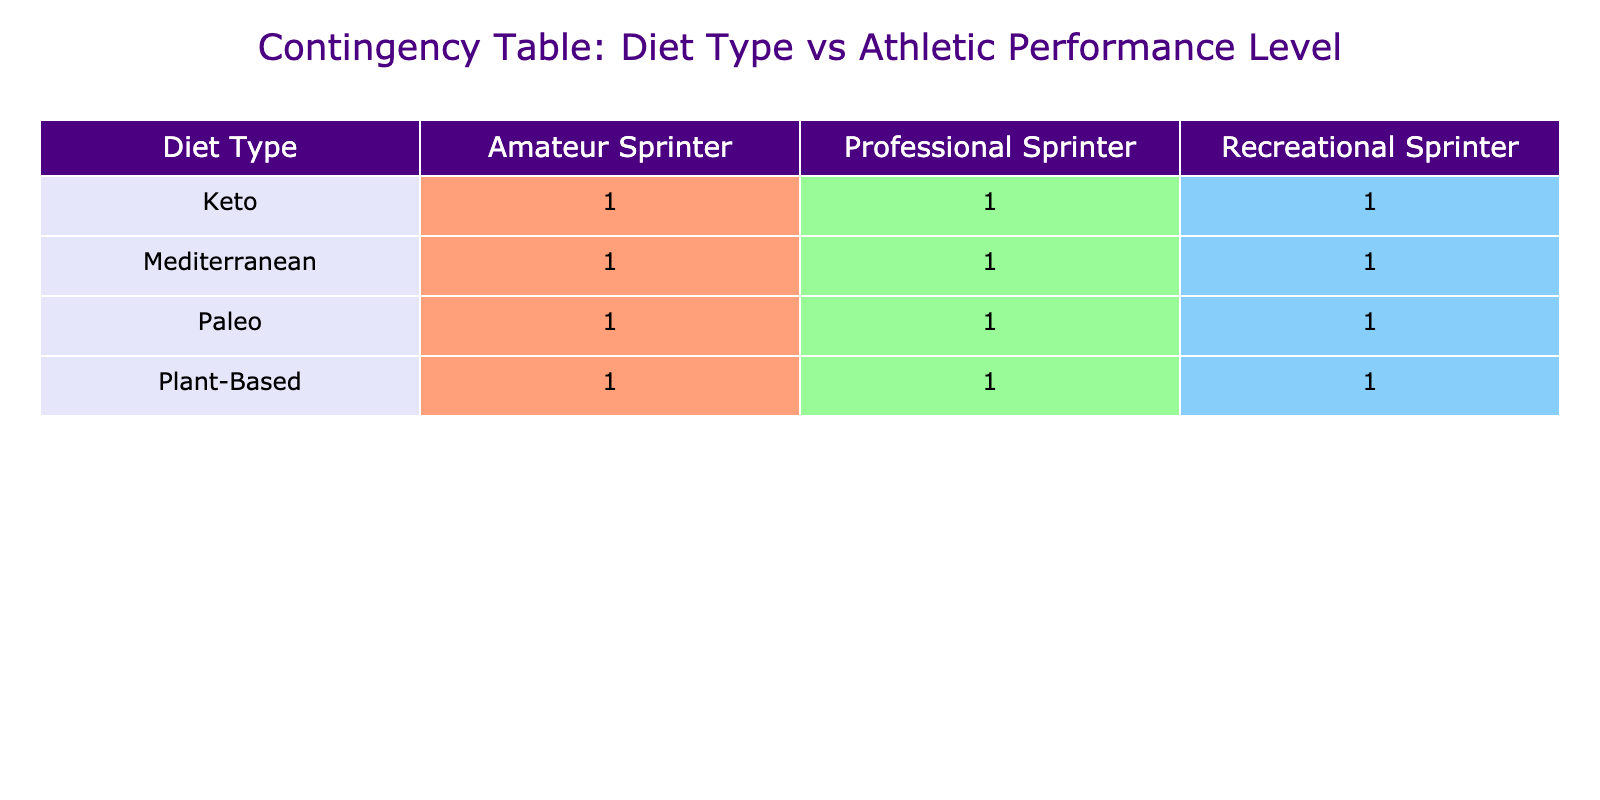What is the daily caloric intake for Professional Sprinters on a Mediterranean diet? From the table, the row for the Mediterranean diet under the Professional Sprinter category shows a daily caloric intake of 2800 calories.
Answer: 2800 calories How many grams of protein do Amateur Sprinters consuming a Keto diet take? Looking at the Keto diet row for the Amateur Sprinter column, the protein intake is listed as 100 grams.
Answer: 100 grams True or False: Recreational Sprinters have a higher average daily caloric intake than Amateur Sprinters across all diet types. To determine this, we calculate the average daily caloric intake for both categories. Recreational Sprinters' intake is (2000 + 2200 + 2100 + 2000) / 4 = 2075. For Amateur Sprinters, it's (2200 + 2400 + 2300 + 2100) / 4 = 2250. Since 2075 is less than 2250, the statement is false.
Answer: False What is the total carbohydrate intake for all Professional Sprinters across the different diets? We can sum the carbohydrate intake for each diet type: Mediterranean (300g) + Plant-Based (350g) + Paleo (200g) + Keto (50g) = 300 + 350 + 200 + 50 = 900 grams.
Answer: 900 grams Which diet type has the highest protein intake for Recreational Sprinters? Referring to the Recreational Sprinter row, the protein intake across diet types is as follows: Keto (70g), Mediterranean (80g), Plant-Based (60g), and Paleo (90g). The highest intake is from the Paleo diet at 90 grams.
Answer: Paleo diet What is the average fat intake for Amateur Sprinters across all diet types? We calculate the total fat intake: Keto (160g) + Mediterranean (80g) + Plant-Based (60g) + Paleo (70g) = 160 + 80 + 60 + 70 = 370 grams. Then, we divide by the number of diet types (4): 370 / 4 = 92.5 grams.
Answer: 92.5 grams True or False: All diet types have the same daily caloric intake for Professional Sprinters. Reviewing the table, the caloric intakes for Professional Sprinters vary: Keto (2500), Mediterranean (2800), Plant-Based (2700), and Paleo (2600). Thus, they do not have the same caloric intake.
Answer: False What is the difference in daily caloric intake between the highest and lowest intake for Recreational Sprinters? The highest caloric intake in the Recreational Sprinter category is from the Mediterranean diet at 2200 calories, and the lowest is from the Keto diet at 2000 calories. The difference is 2200 - 2000 = 200 calories.
Answer: 200 calories 